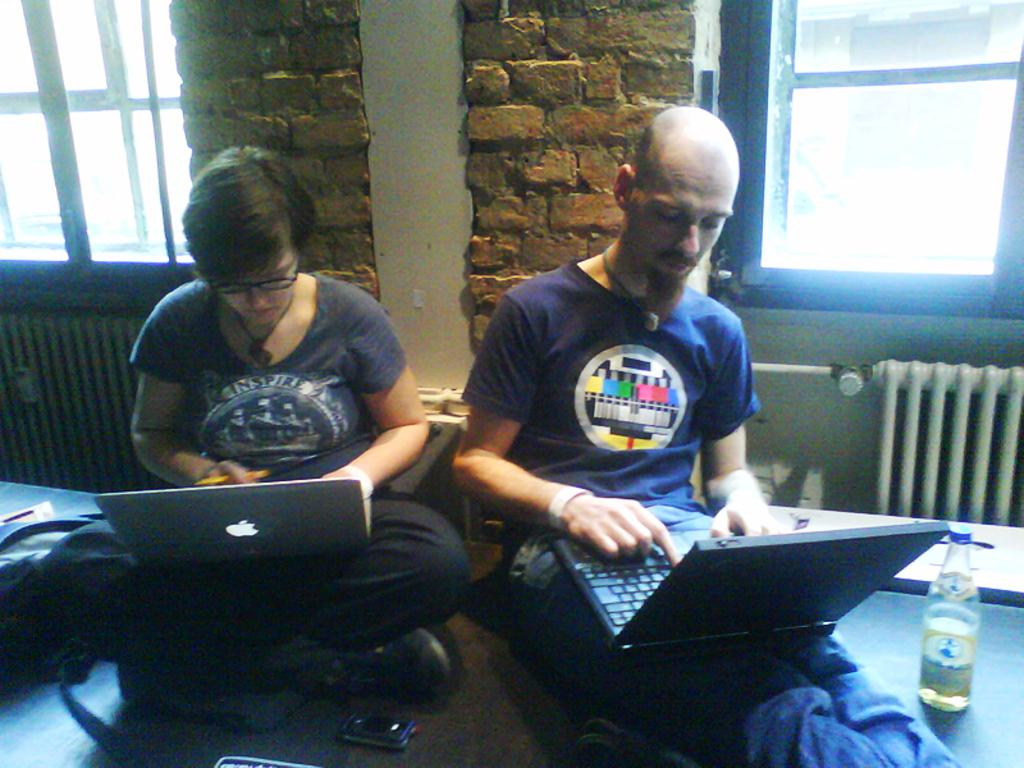Who is present in the image? There is a man and a woman in the image. What are the man and woman doing in the image? Both the man and woman are sitting on the floor. What are they using while sitting on the floor? The man and woman have laptops in their laps. Can you describe any other objects in the image? There is a bottle and a mobile in the image. What is the wall made of in the image? The wall in the image is made up of bricks. How many windows can be seen in the image? There are two windows in the image. What type of joke is the man telling the woman in the image? There is no indication of a joke being told in the image; the man and woman are both focused on their laptops. 